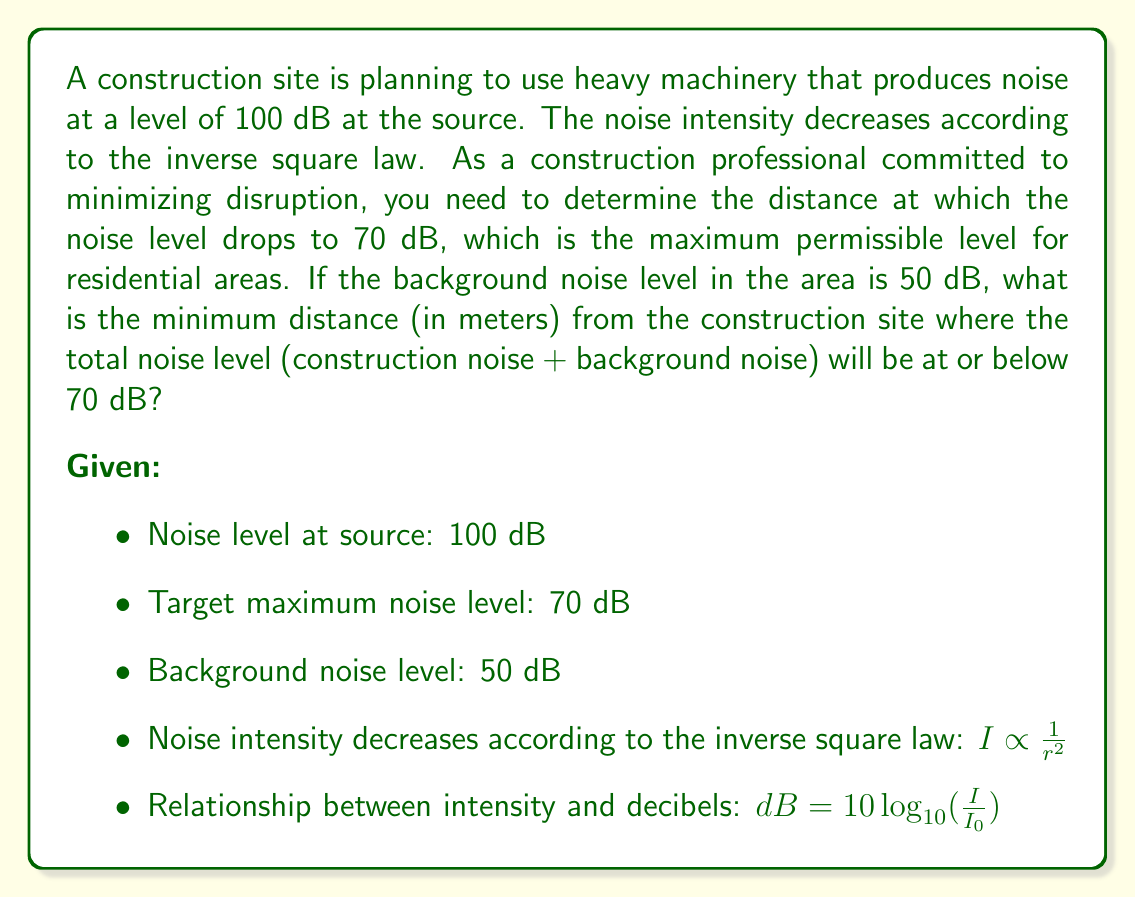What is the answer to this math problem? To solve this problem, we'll follow these steps:

1) First, we need to calculate the distance at which the construction noise alone drops to 70 dB.

2) Then, we'll check if this distance is sufficient to ensure that the total noise level (construction + background) is at or below 70 dB.

3) If not, we'll calculate the required distance for the total noise to be 70 dB.

Step 1: Calculate distance for construction noise to drop to 70 dB

Let's use the inverse square law and the decibel formula:

$$ \frac{I_1}{I_2} = \left(\frac{r_2}{r_1}\right)^2 $$

$$ dB_1 - dB_2 = 10 \log_{10}\left(\frac{I_1}{I_2}\right) $$

Combining these equations:

$$ 100 - 70 = 10 log_{10}\left(\frac{r^2}{1^2}\right) $$

$$ 30 = 20 \log_{10}(r) $$

$$ r = 10^{1.5} \approx 31.62 \text{ meters} $$

Step 2: Check if this distance is sufficient for total noise ≤ 70 dB

At 31.62 meters:
Construction noise: 70 dB
Background noise: 50 dB

To combine decibels, we use:

$$ dB_{total} = 10 \log_{10}(10^{dB_1/10} + 10^{dB_2/10}) $$

$$ dB_{total} = 10 \log_{10}(10^{70/10} + 10^{50/10}) \approx 70.13 \text{ dB} $$

This is slightly above 70 dB, so we need to increase the distance.

Step 3: Calculate required distance for total noise to be 70 dB

Let x be the factor by which we need to increase the distance. The construction noise will decrease by $20\log_{10}(x)$ dB.

$$ 70 = 10 \log_{10}(10^{(70-20\log_{10}(x))/10} + 10^{50/10}) $$

Solving this equation numerically, we get x ≈ 1.0307.

Therefore, the required distance is:

$$ 31.62 * 1.0307 \approx 32.59 \text{ meters} $$
Answer: The minimum distance from the construction site where the total noise level will be at or below 70 dB is approximately 32.59 meters. 